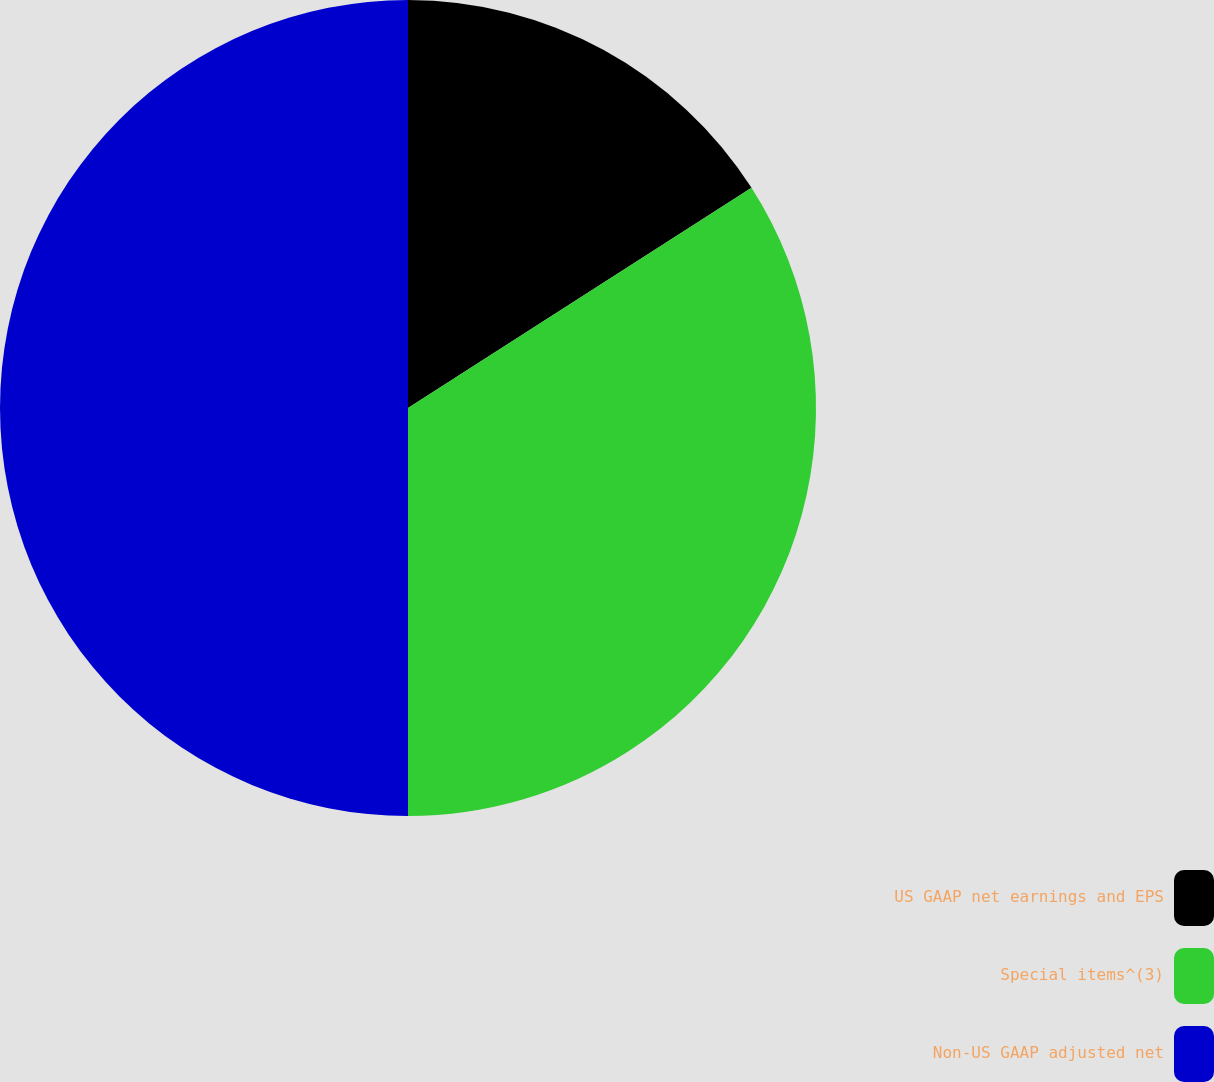Convert chart to OTSL. <chart><loc_0><loc_0><loc_500><loc_500><pie_chart><fcel>US GAAP net earnings and EPS<fcel>Special items^(3)<fcel>Non-US GAAP adjusted net<nl><fcel>15.93%<fcel>34.07%<fcel>50.0%<nl></chart> 